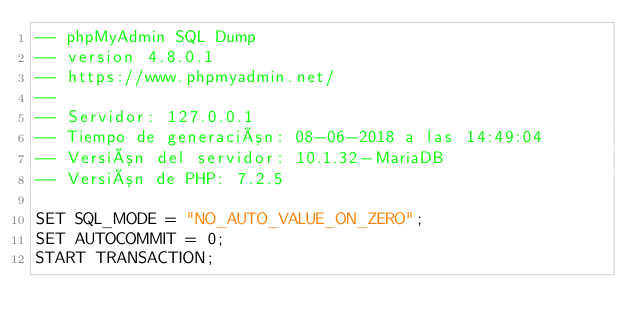Convert code to text. <code><loc_0><loc_0><loc_500><loc_500><_SQL_>-- phpMyAdmin SQL Dump
-- version 4.8.0.1
-- https://www.phpmyadmin.net/
--
-- Servidor: 127.0.0.1
-- Tiempo de generación: 08-06-2018 a las 14:49:04
-- Versión del servidor: 10.1.32-MariaDB
-- Versión de PHP: 7.2.5

SET SQL_MODE = "NO_AUTO_VALUE_ON_ZERO";
SET AUTOCOMMIT = 0;
START TRANSACTION;</code> 